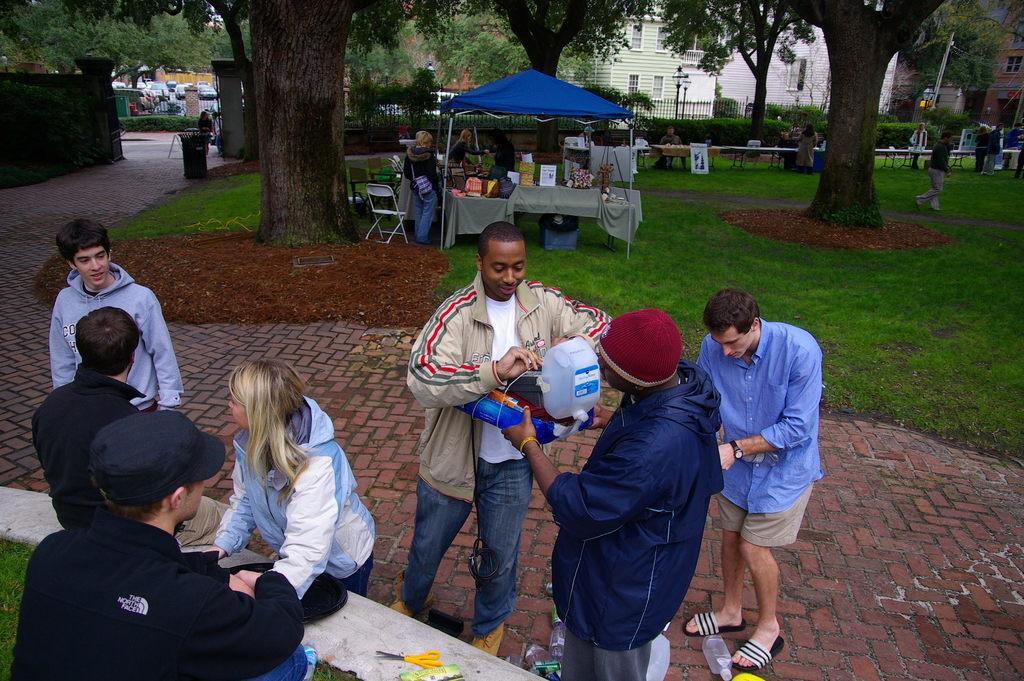Please provide a concise description of this image. In this image I can see group of people some are sitting and some are standing. The person in front is wearing white and blue color jacket and blue color pant, the person at right is holding some object. Background I can see a tent in blue color and few objects on the table, trees in green color, buildings in white and cream color. 